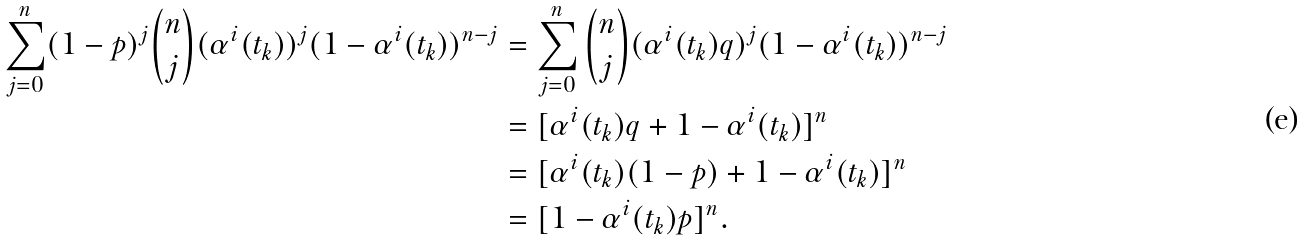Convert formula to latex. <formula><loc_0><loc_0><loc_500><loc_500>\sum _ { j = 0 } ^ { n } ( 1 - p ) ^ { j } \binom { n } { j } ( \alpha ^ { i } ( t _ { k } ) ) ^ { j } ( 1 - \alpha ^ { i } ( t _ { k } ) ) ^ { n - j } & = \sum _ { j = 0 } ^ { n } \binom { n } { j } ( \alpha ^ { i } ( t _ { k } ) q ) ^ { j } ( 1 - \alpha ^ { i } ( t _ { k } ) ) ^ { n - j } \\ & = [ \alpha ^ { i } ( t _ { k } ) q + 1 - \alpha ^ { i } ( t _ { k } ) ] ^ { n } \\ & = [ \alpha ^ { i } ( t _ { k } ) ( 1 - p ) + 1 - \alpha ^ { i } ( t _ { k } ) ] ^ { n } \\ & = [ 1 - \alpha ^ { i } ( t _ { k } ) p ] ^ { n } .</formula> 